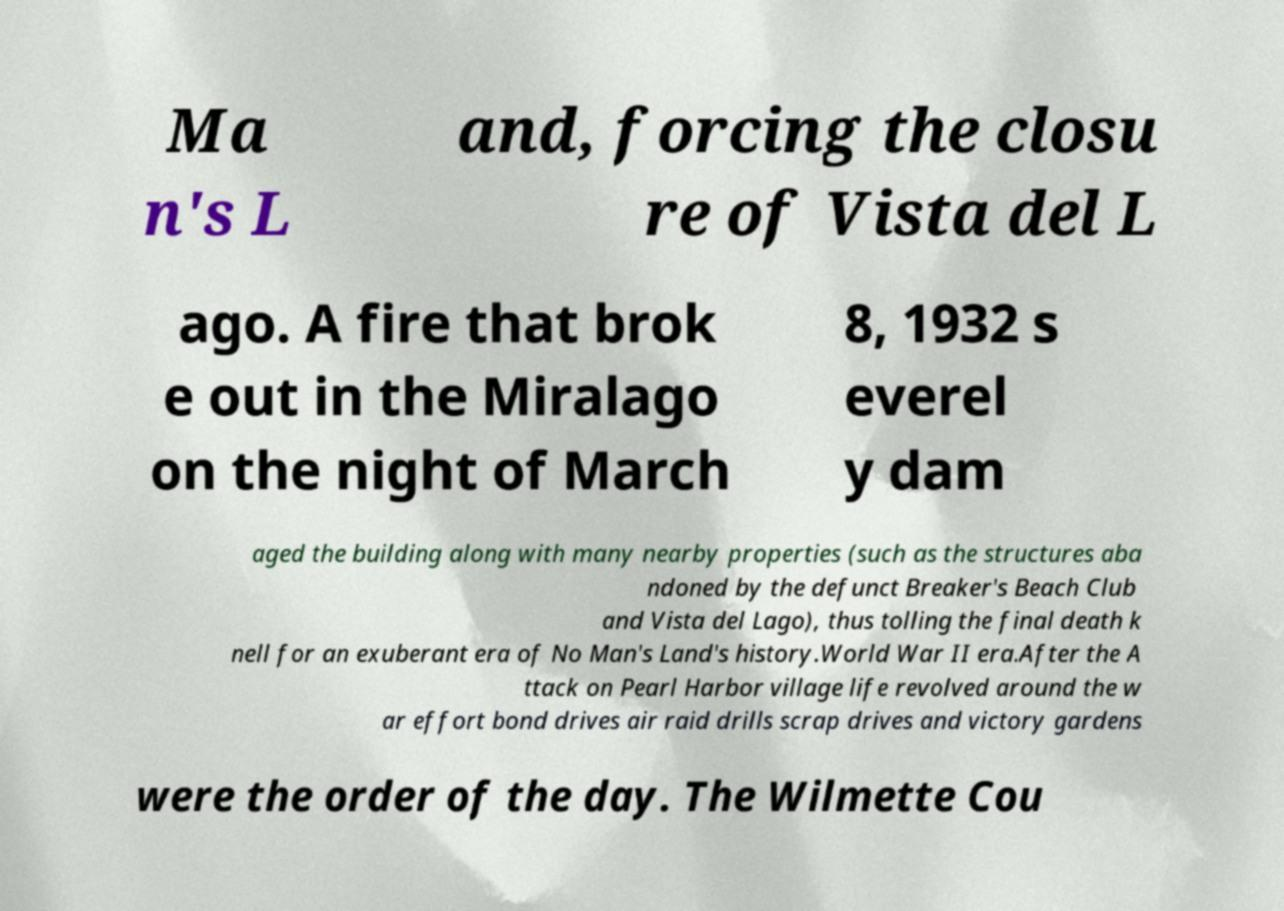I need the written content from this picture converted into text. Can you do that? Ma n's L and, forcing the closu re of Vista del L ago. A fire that brok e out in the Miralago on the night of March 8, 1932 s everel y dam aged the building along with many nearby properties (such as the structures aba ndoned by the defunct Breaker's Beach Club and Vista del Lago), thus tolling the final death k nell for an exuberant era of No Man's Land's history.World War II era.After the A ttack on Pearl Harbor village life revolved around the w ar effort bond drives air raid drills scrap drives and victory gardens were the order of the day. The Wilmette Cou 